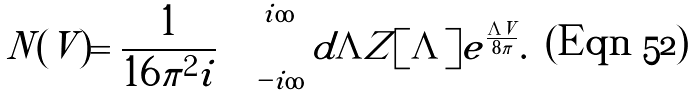<formula> <loc_0><loc_0><loc_500><loc_500>N ( V ) = \frac { 1 } { 1 6 \pi ^ { 2 } i } \int _ { - i \infty } ^ { i \infty } d \Lambda Z [ \Lambda ] e ^ { \frac { \Lambda V } { 8 \pi } } .</formula> 